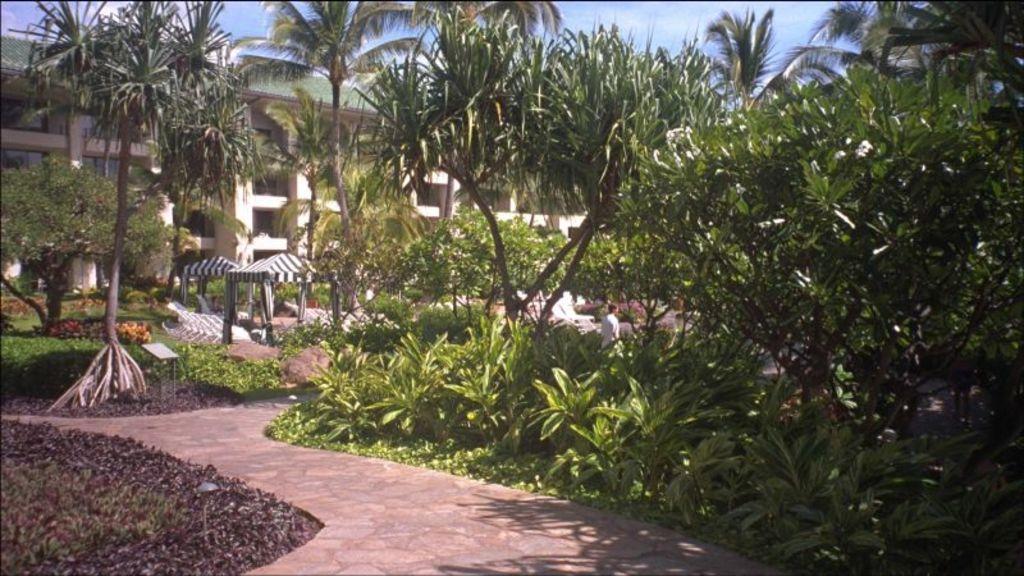Can you describe this image briefly? In this image I can see a path in the centre and on the both sides of the path I can see number of trees, number of plants and grass. In the background I can see a building, clouds and the sky. In the centre of the image I can see few open tent sheds, number of chairs and one person. I can also see few shadows on the ground. 